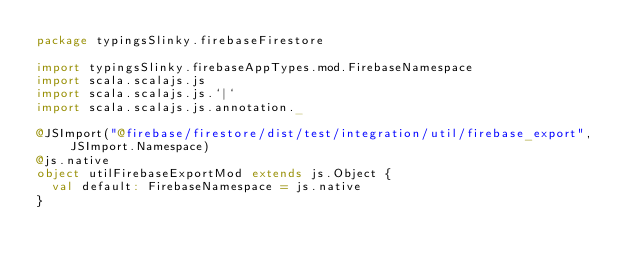Convert code to text. <code><loc_0><loc_0><loc_500><loc_500><_Scala_>package typingsSlinky.firebaseFirestore

import typingsSlinky.firebaseAppTypes.mod.FirebaseNamespace
import scala.scalajs.js
import scala.scalajs.js.`|`
import scala.scalajs.js.annotation._

@JSImport("@firebase/firestore/dist/test/integration/util/firebase_export", JSImport.Namespace)
@js.native
object utilFirebaseExportMod extends js.Object {
  val default: FirebaseNamespace = js.native
}

</code> 